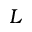Convert formula to latex. <formula><loc_0><loc_0><loc_500><loc_500>L</formula> 